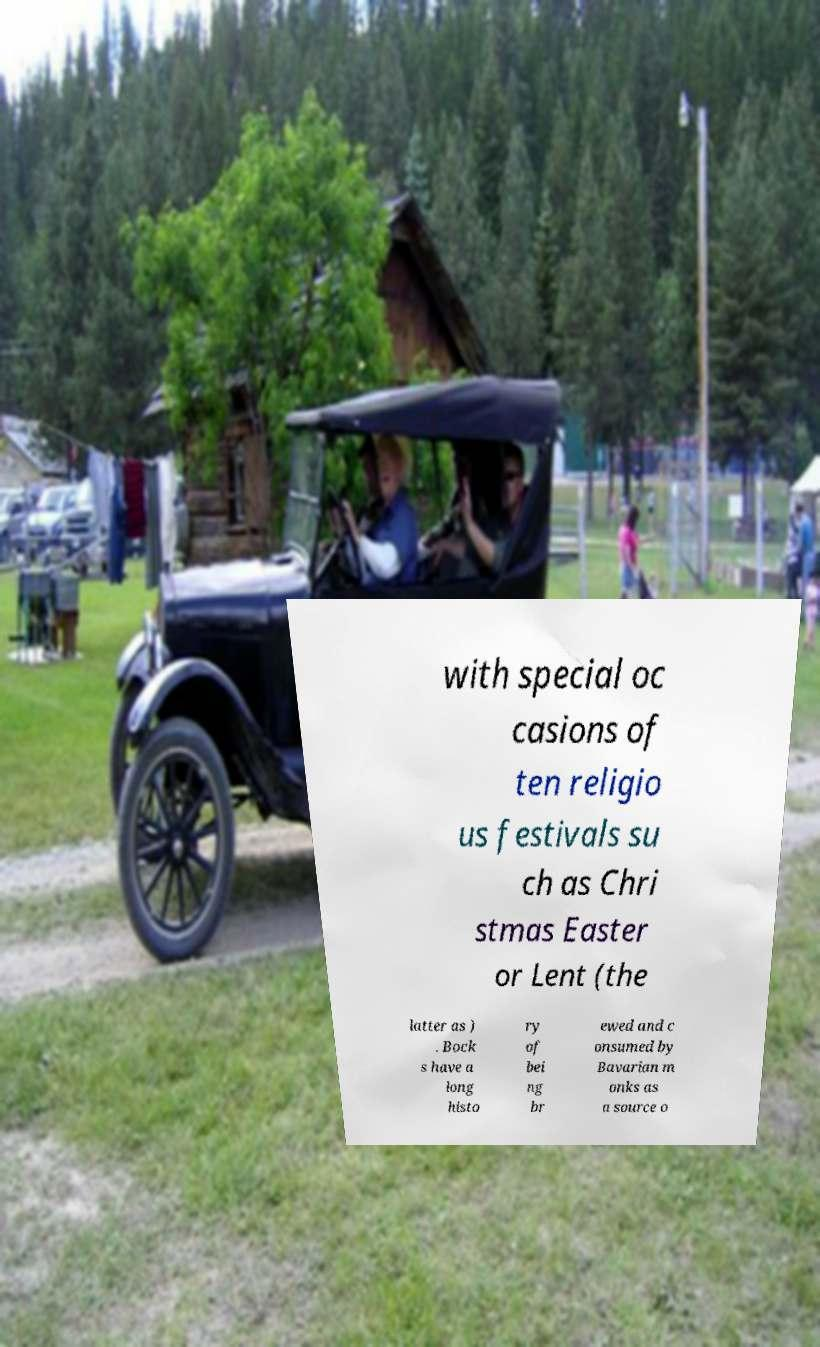I need the written content from this picture converted into text. Can you do that? with special oc casions of ten religio us festivals su ch as Chri stmas Easter or Lent (the latter as ) . Bock s have a long histo ry of bei ng br ewed and c onsumed by Bavarian m onks as a source o 